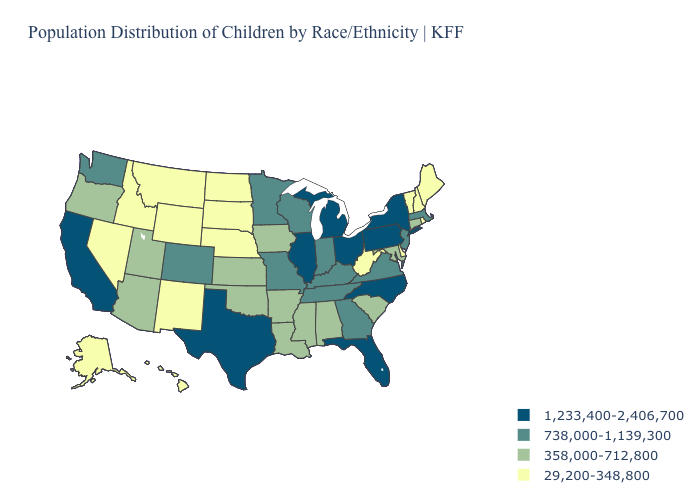Name the states that have a value in the range 738,000-1,139,300?
Concise answer only. Colorado, Georgia, Indiana, Kentucky, Massachusetts, Minnesota, Missouri, New Jersey, Tennessee, Virginia, Washington, Wisconsin. What is the value of California?
Keep it brief. 1,233,400-2,406,700. How many symbols are there in the legend?
Short answer required. 4. Does Wyoming have a lower value than Vermont?
Answer briefly. No. Name the states that have a value in the range 358,000-712,800?
Keep it brief. Alabama, Arizona, Arkansas, Connecticut, Iowa, Kansas, Louisiana, Maryland, Mississippi, Oklahoma, Oregon, South Carolina, Utah. Name the states that have a value in the range 358,000-712,800?
Write a very short answer. Alabama, Arizona, Arkansas, Connecticut, Iowa, Kansas, Louisiana, Maryland, Mississippi, Oklahoma, Oregon, South Carolina, Utah. Name the states that have a value in the range 29,200-348,800?
Quick response, please. Alaska, Delaware, Hawaii, Idaho, Maine, Montana, Nebraska, Nevada, New Hampshire, New Mexico, North Dakota, Rhode Island, South Dakota, Vermont, West Virginia, Wyoming. Name the states that have a value in the range 29,200-348,800?
Answer briefly. Alaska, Delaware, Hawaii, Idaho, Maine, Montana, Nebraska, Nevada, New Hampshire, New Mexico, North Dakota, Rhode Island, South Dakota, Vermont, West Virginia, Wyoming. What is the value of Delaware?
Quick response, please. 29,200-348,800. Among the states that border Connecticut , which have the lowest value?
Answer briefly. Rhode Island. What is the lowest value in states that border New Jersey?
Keep it brief. 29,200-348,800. How many symbols are there in the legend?
Give a very brief answer. 4. Which states have the lowest value in the USA?
Short answer required. Alaska, Delaware, Hawaii, Idaho, Maine, Montana, Nebraska, Nevada, New Hampshire, New Mexico, North Dakota, Rhode Island, South Dakota, Vermont, West Virginia, Wyoming. Which states have the lowest value in the Northeast?
Be succinct. Maine, New Hampshire, Rhode Island, Vermont. Which states have the lowest value in the West?
Give a very brief answer. Alaska, Hawaii, Idaho, Montana, Nevada, New Mexico, Wyoming. 